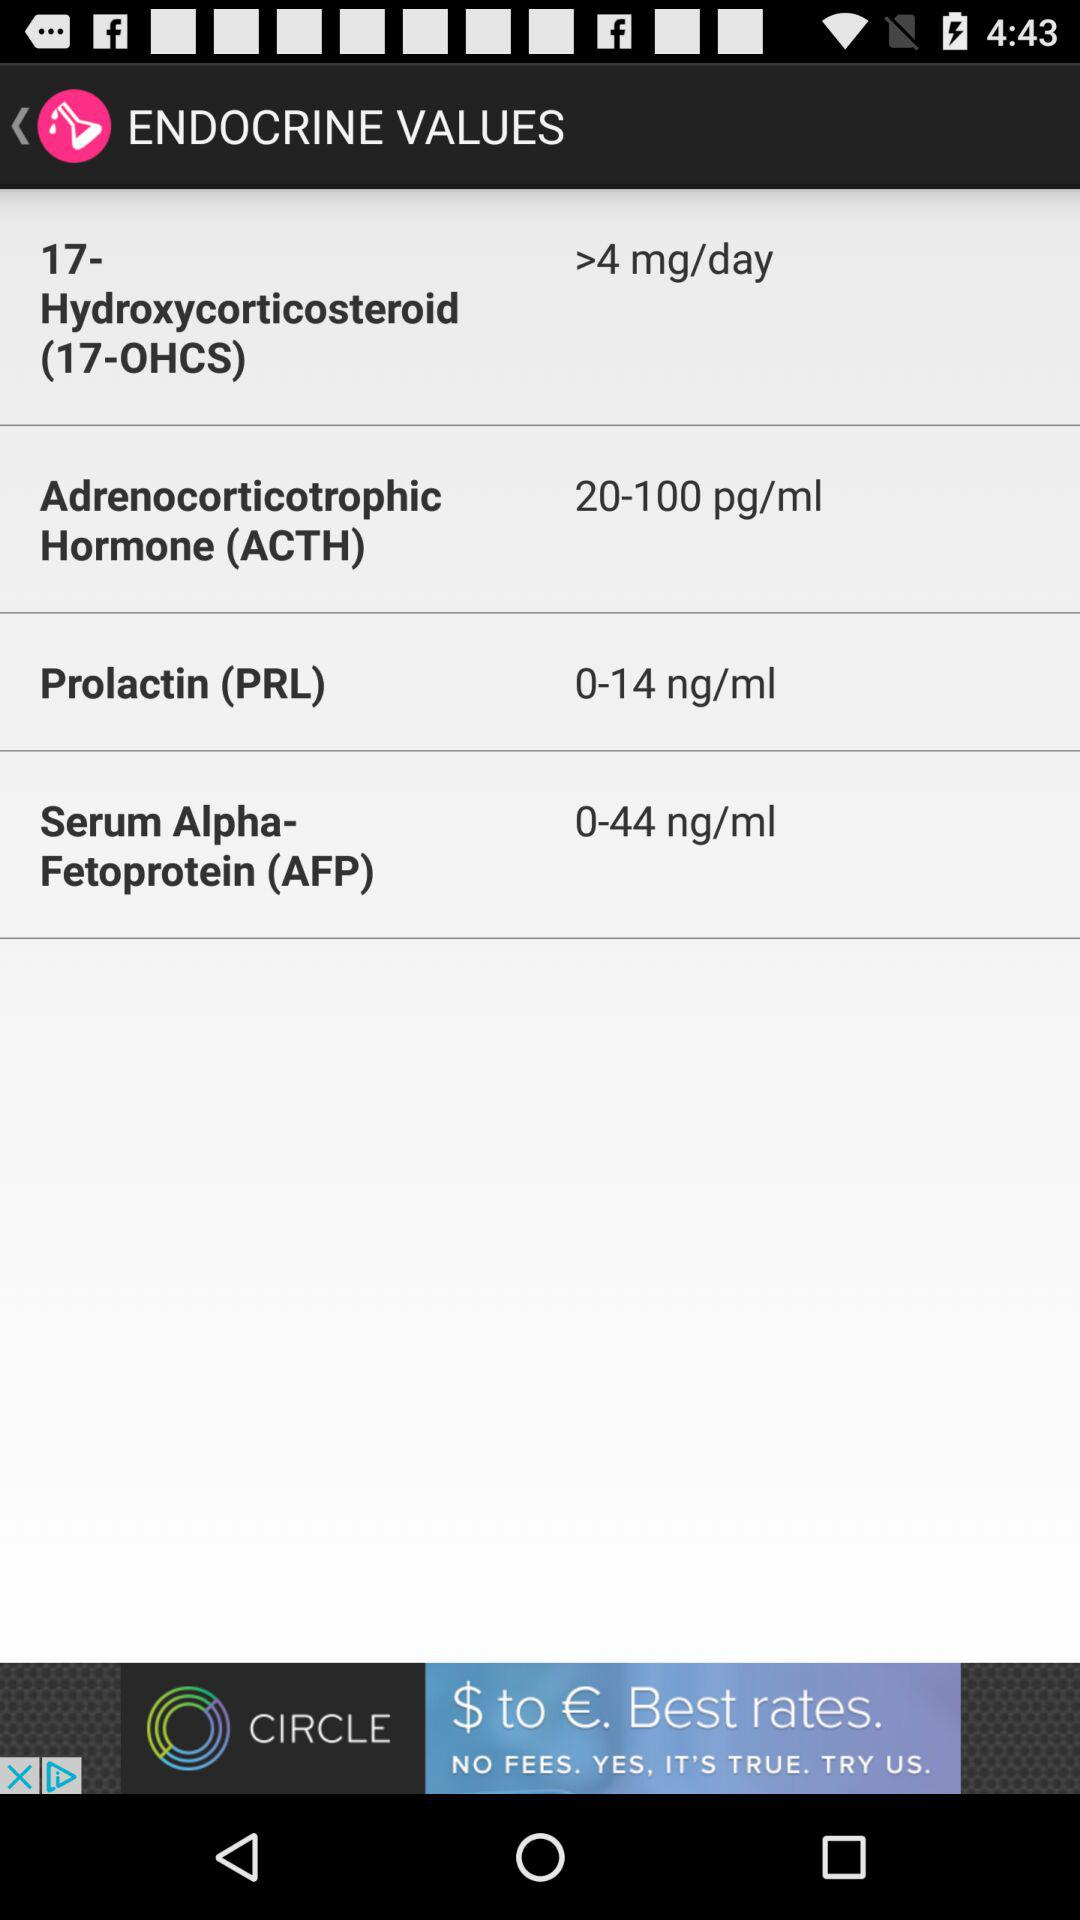What is the value of prolactin (PRL) per ml? The value of prolactin (PRL) is 0–14 ng/ml. 